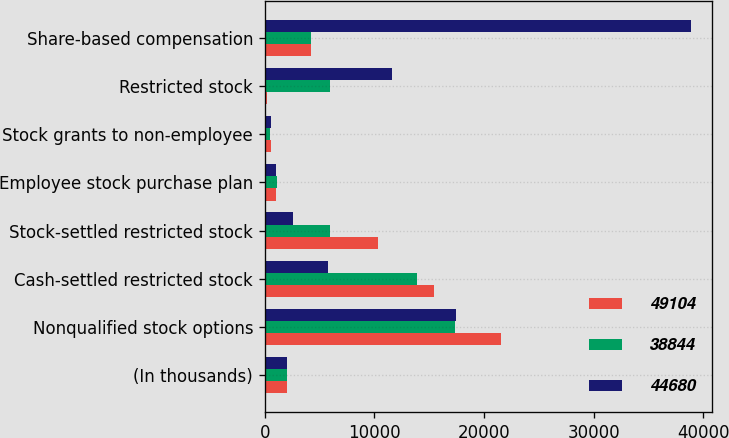<chart> <loc_0><loc_0><loc_500><loc_500><stacked_bar_chart><ecel><fcel>(In thousands)<fcel>Nonqualified stock options<fcel>Cash-settled restricted stock<fcel>Stock-settled restricted stock<fcel>Employee stock purchase plan<fcel>Stock grants to non-employee<fcel>Restricted stock<fcel>Share-based compensation<nl><fcel>49104<fcel>2012<fcel>21581<fcel>15435<fcel>10360<fcel>1015<fcel>550<fcel>163<fcel>4166<nl><fcel>38844<fcel>2011<fcel>17302<fcel>13917<fcel>5948<fcel>1074<fcel>475<fcel>5964<fcel>4166<nl><fcel>44680<fcel>2010<fcel>17404<fcel>5718<fcel>2614<fcel>987<fcel>550<fcel>11571<fcel>38844<nl></chart> 